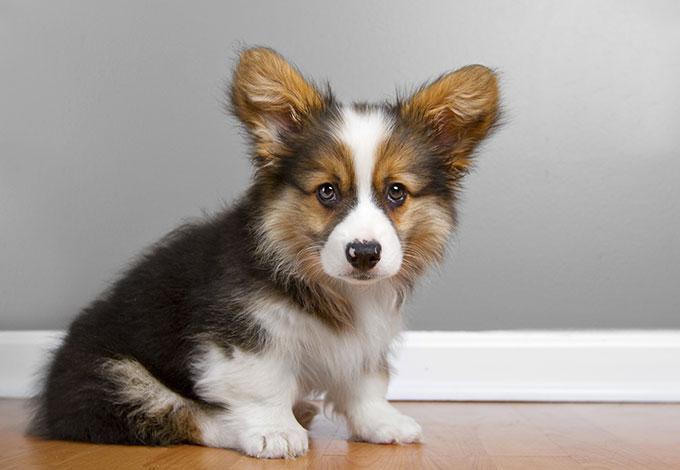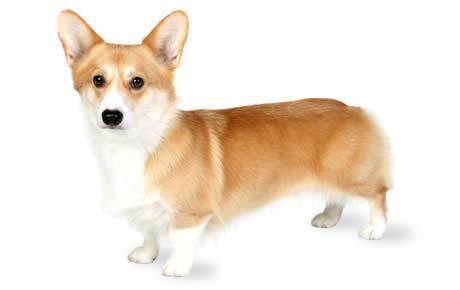The first image is the image on the left, the second image is the image on the right. Considering the images on both sides, is "There are two dogs with tongue sticking out." valid? Answer yes or no. No. 